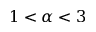Convert formula to latex. <formula><loc_0><loc_0><loc_500><loc_500>1 < \alpha < 3</formula> 